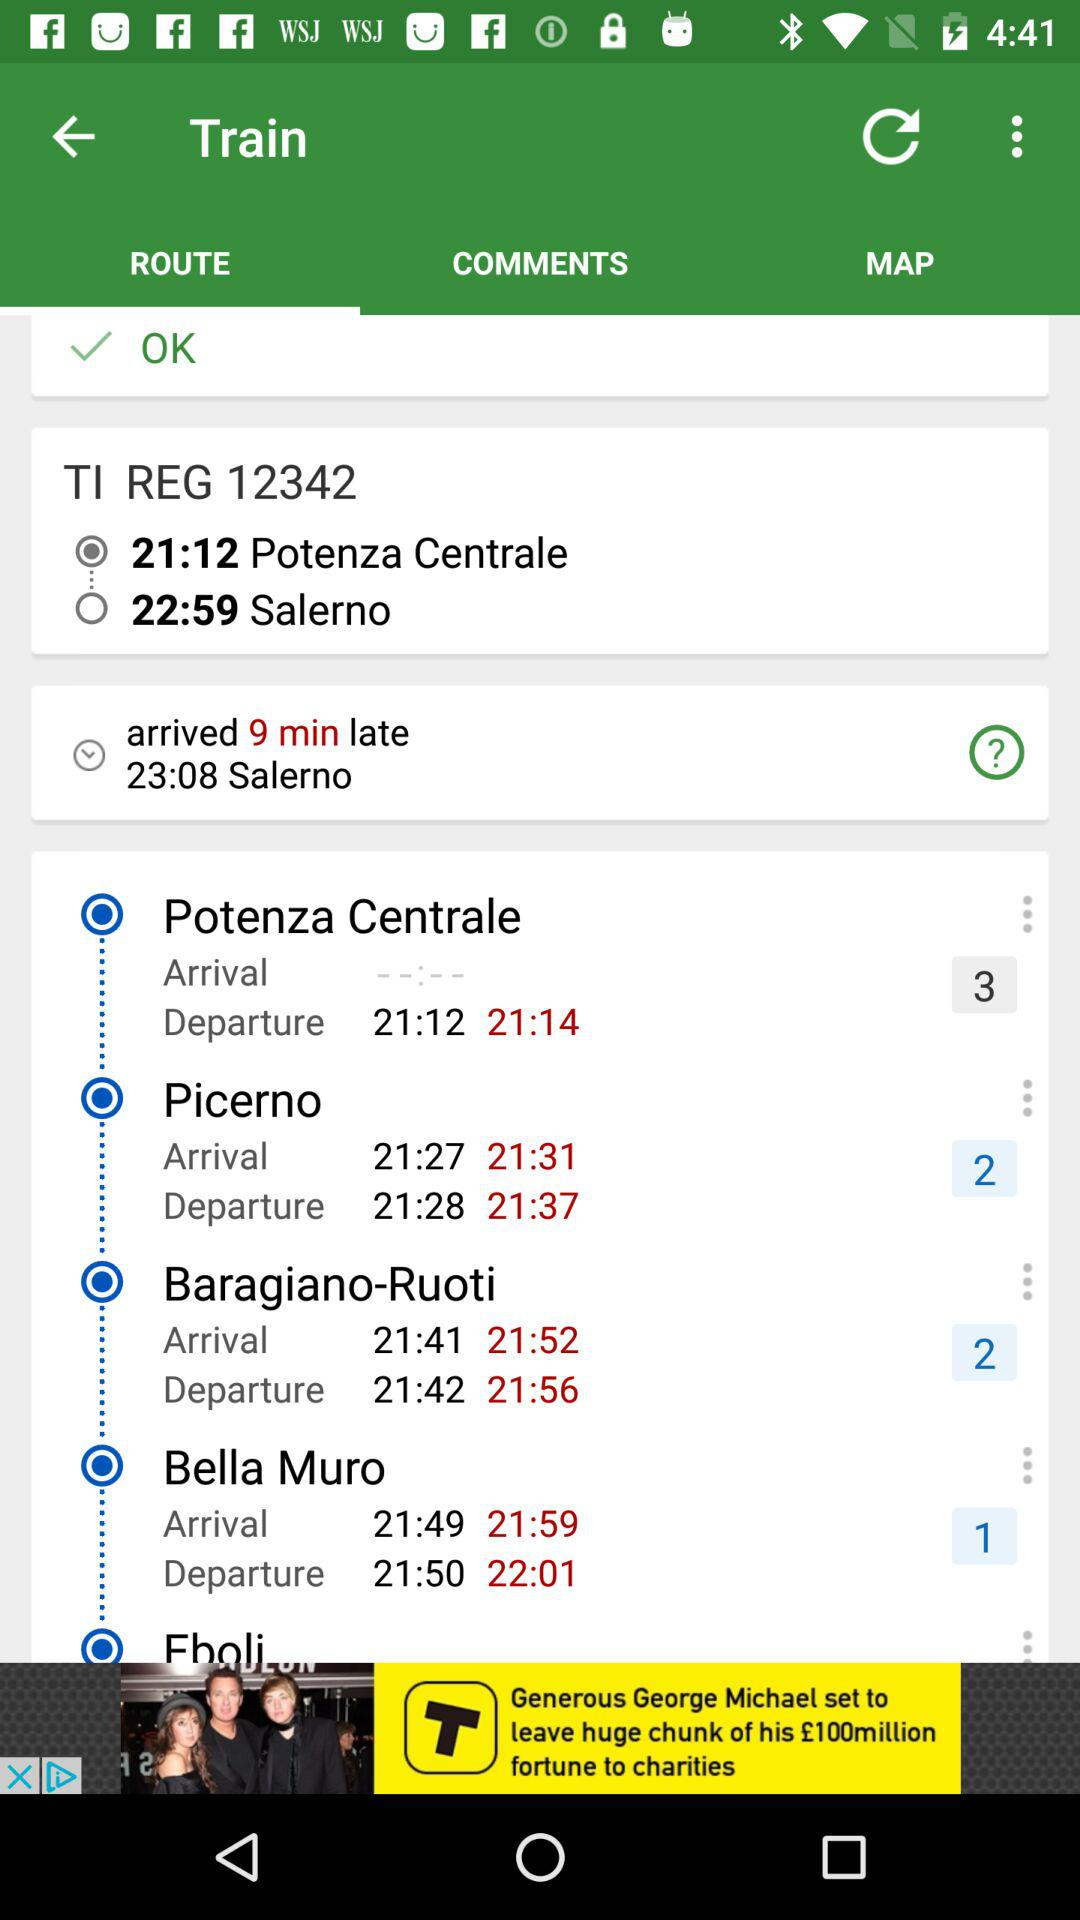Which tab is selected right now? The selected tab is "ROUTE". 